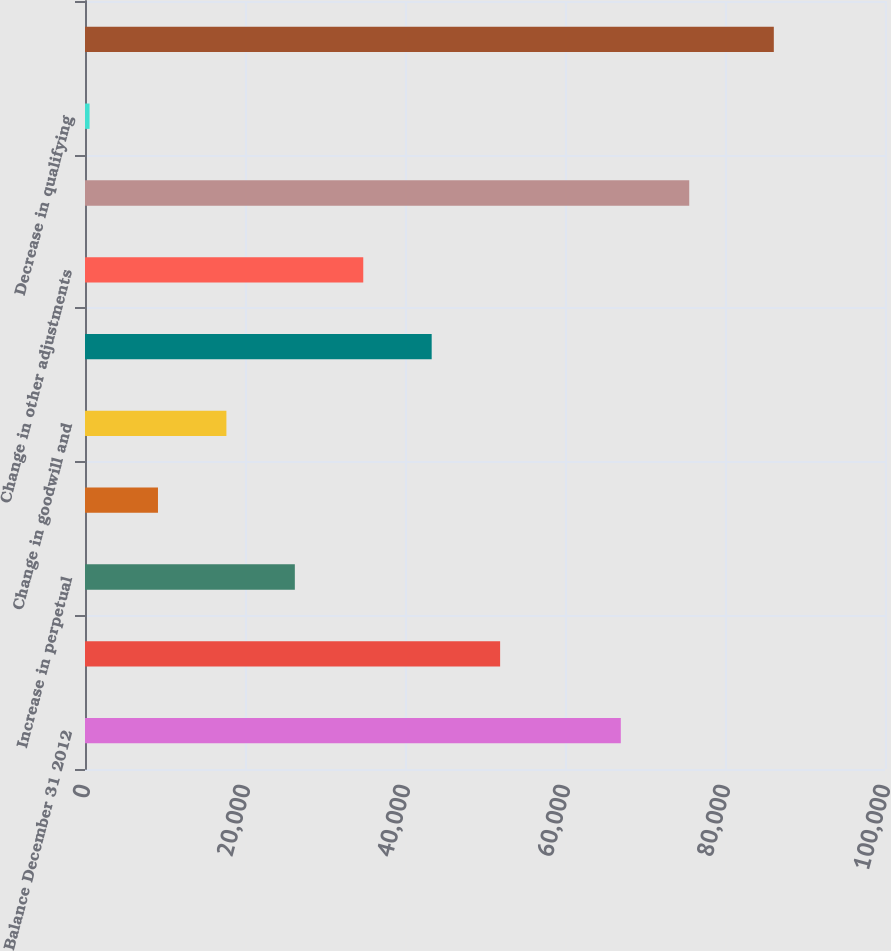Convert chart to OTSL. <chart><loc_0><loc_0><loc_500><loc_500><bar_chart><fcel>Balance December 31 2012<fcel>Increase in common<fcel>Increase in perpetual<fcel>Redesignation of junior<fcel>Change in goodwill and<fcel>Change in equity investments<fcel>Change in other adjustments<fcel>Balance December 31 2013<fcel>Decrease in qualifying<fcel>Total capital<nl><fcel>66977<fcel>51889.4<fcel>26229.2<fcel>9122.4<fcel>17675.8<fcel>43336<fcel>34782.6<fcel>75530.4<fcel>569<fcel>86103<nl></chart> 